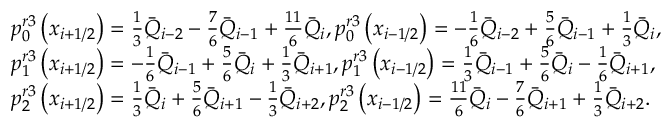Convert formula to latex. <formula><loc_0><loc_0><loc_500><loc_500>\begin{array} { r l } & { p _ { 0 } ^ { r 3 } \left ( { { x } _ { i + 1 / 2 } } \right ) = \frac { 1 } { 3 } { { { \bar { Q } } } _ { i - 2 } } - \frac { 7 } { 6 } { { { \bar { Q } } } _ { i - 1 } } + \frac { 1 1 } { 6 } { { { \bar { Q } } } _ { i } } , p _ { 0 } ^ { r 3 } \left ( { { x } _ { i - 1 / 2 } } \right ) = - \frac { 1 } { 6 } { { { \bar { Q } } } _ { i - 2 } } + \frac { 5 } { 6 } { { { \bar { Q } } } _ { i - 1 } } + \frac { 1 } { 3 } { { { \bar { Q } } } _ { i } } , } \\ & { p _ { 1 } ^ { r 3 } \left ( { { x } _ { i + 1 / 2 } } \right ) = - \frac { 1 } { 6 } { { { \bar { Q } } } _ { i - 1 } } + \frac { 5 } { 6 } { { { \bar { Q } } } _ { i } } + \frac { 1 } { 3 } { { { \bar { Q } } } _ { i + 1 } } , p _ { 1 } ^ { r 3 } \left ( { { x } _ { i - 1 / 2 } } \right ) = \frac { 1 } { 3 } { { { \bar { Q } } } _ { i - 1 } } + \frac { 5 } { 6 } { { { \bar { Q } } } _ { i } } - \frac { 1 } { 6 } { { { \bar { Q } } } _ { i + 1 } } , } \\ & { p _ { 2 } ^ { r 3 } \left ( { { x } _ { i + 1 / 2 } } \right ) = \frac { 1 } { 3 } { { { \bar { Q } } } _ { i } } + \frac { 5 } { 6 } { { { \bar { Q } } } _ { i + 1 } } - \frac { 1 } { 3 } { { { \bar { Q } } } _ { i + 2 } } , p _ { 2 } ^ { r 3 } \left ( { { x } _ { i - 1 / 2 } } \right ) = \frac { 1 1 } { 6 } { { { \bar { Q } } } _ { i } } - \frac { 7 } { 6 } { { { \bar { Q } } } _ { i + 1 } } + \frac { 1 } { 3 } { { { \bar { Q } } } _ { i + 2 } } . } \end{array}</formula> 